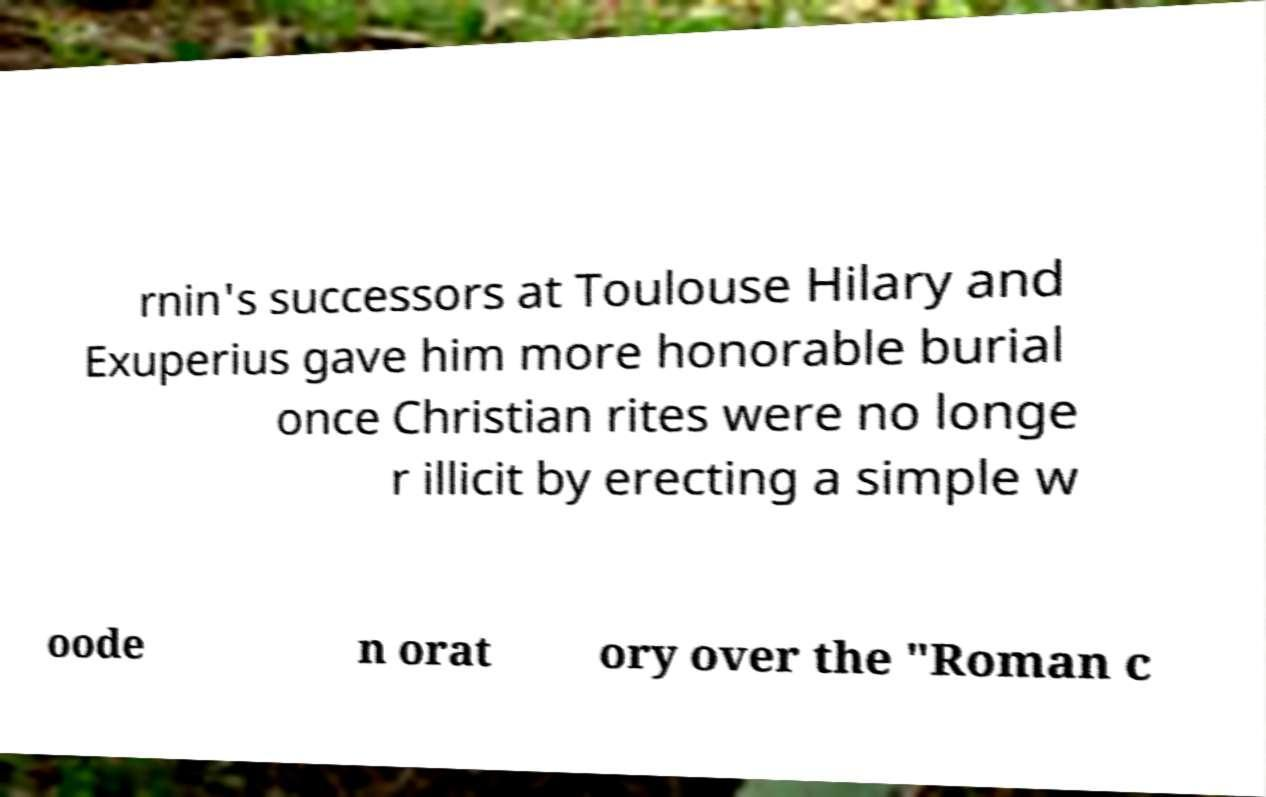There's text embedded in this image that I need extracted. Can you transcribe it verbatim? rnin's successors at Toulouse Hilary and Exuperius gave him more honorable burial once Christian rites were no longe r illicit by erecting a simple w oode n orat ory over the "Roman c 